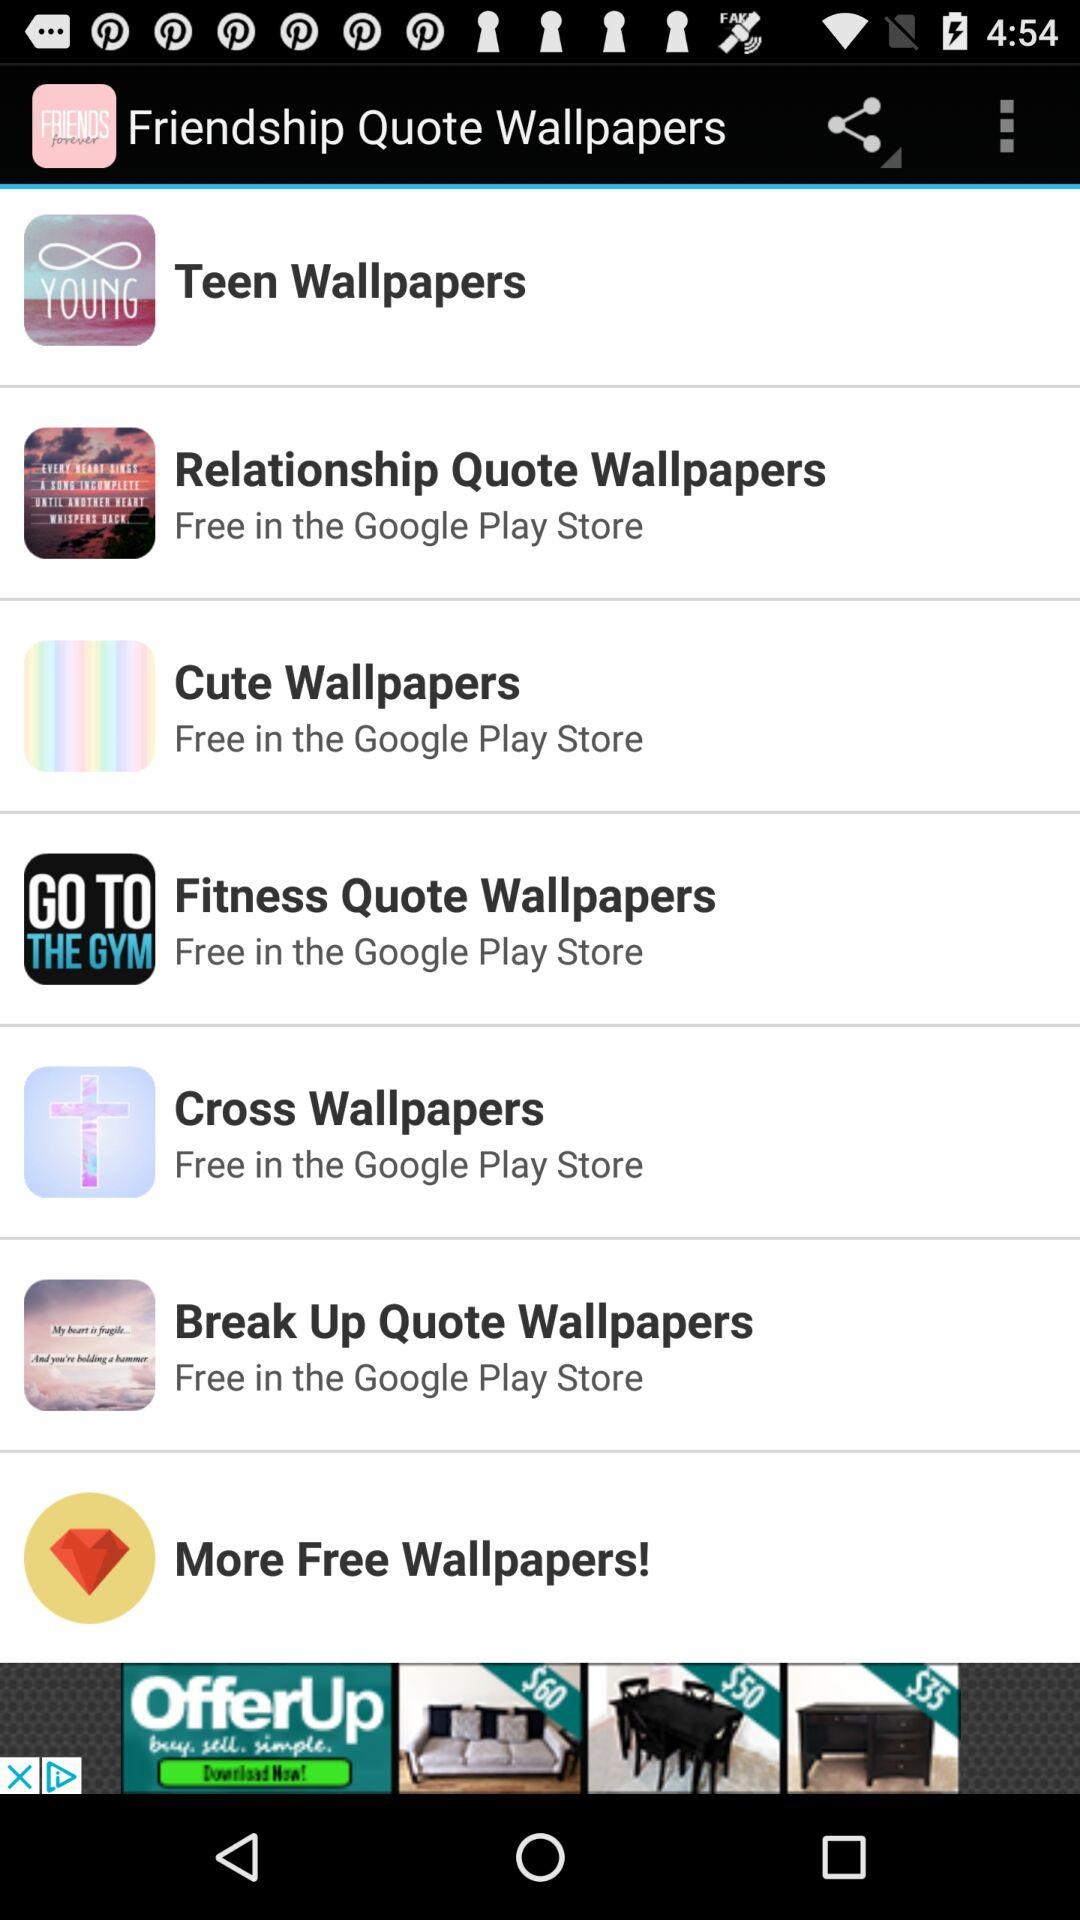Where can the user get free "Cross Wallpapers"? The user can get free "Cross Wallpapers" in the "Google Play Store". 